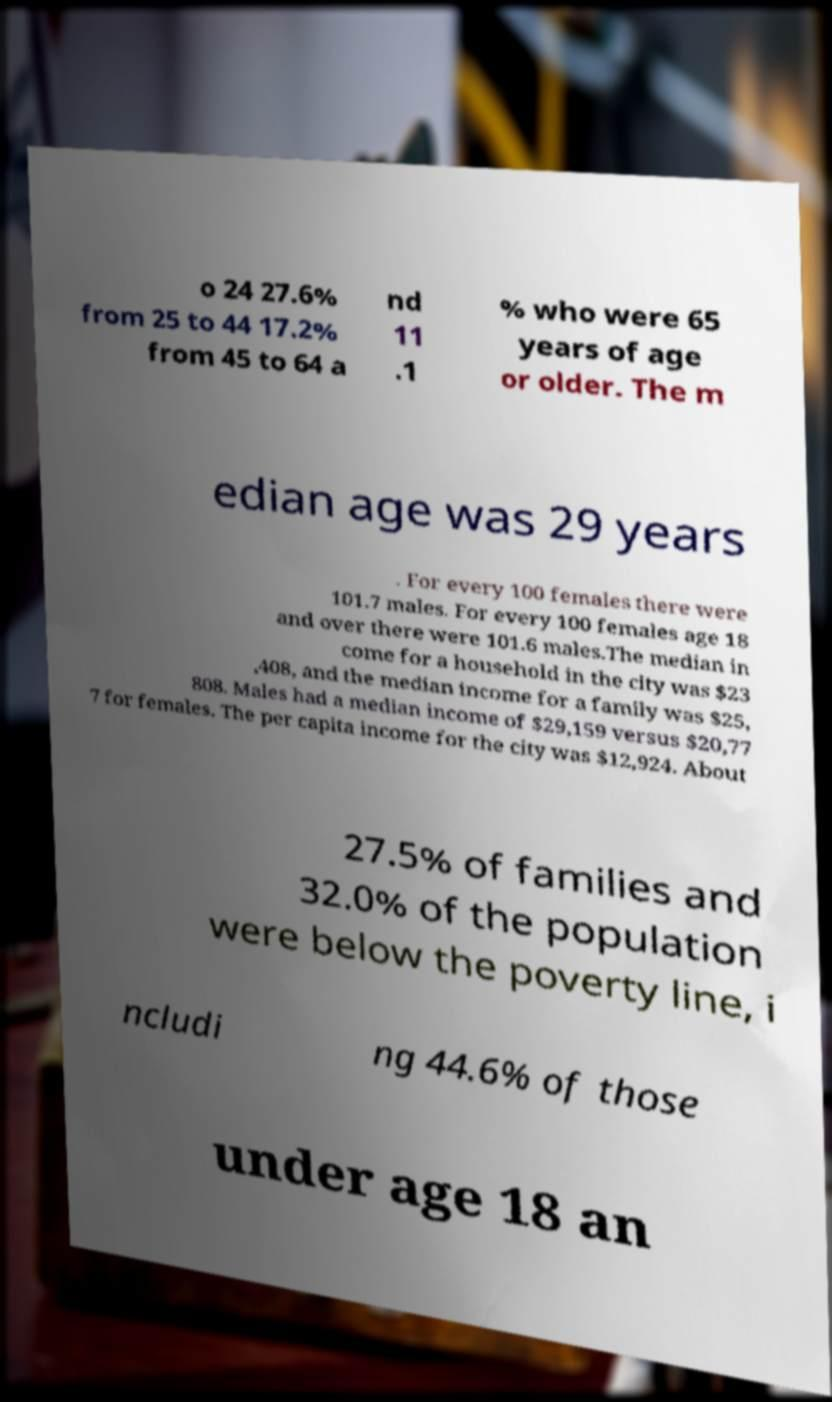Could you assist in decoding the text presented in this image and type it out clearly? o 24 27.6% from 25 to 44 17.2% from 45 to 64 a nd 11 .1 % who were 65 years of age or older. The m edian age was 29 years . For every 100 females there were 101.7 males. For every 100 females age 18 and over there were 101.6 males.The median in come for a household in the city was $23 ,408, and the median income for a family was $25, 808. Males had a median income of $29,159 versus $20,77 7 for females. The per capita income for the city was $12,924. About 27.5% of families and 32.0% of the population were below the poverty line, i ncludi ng 44.6% of those under age 18 an 